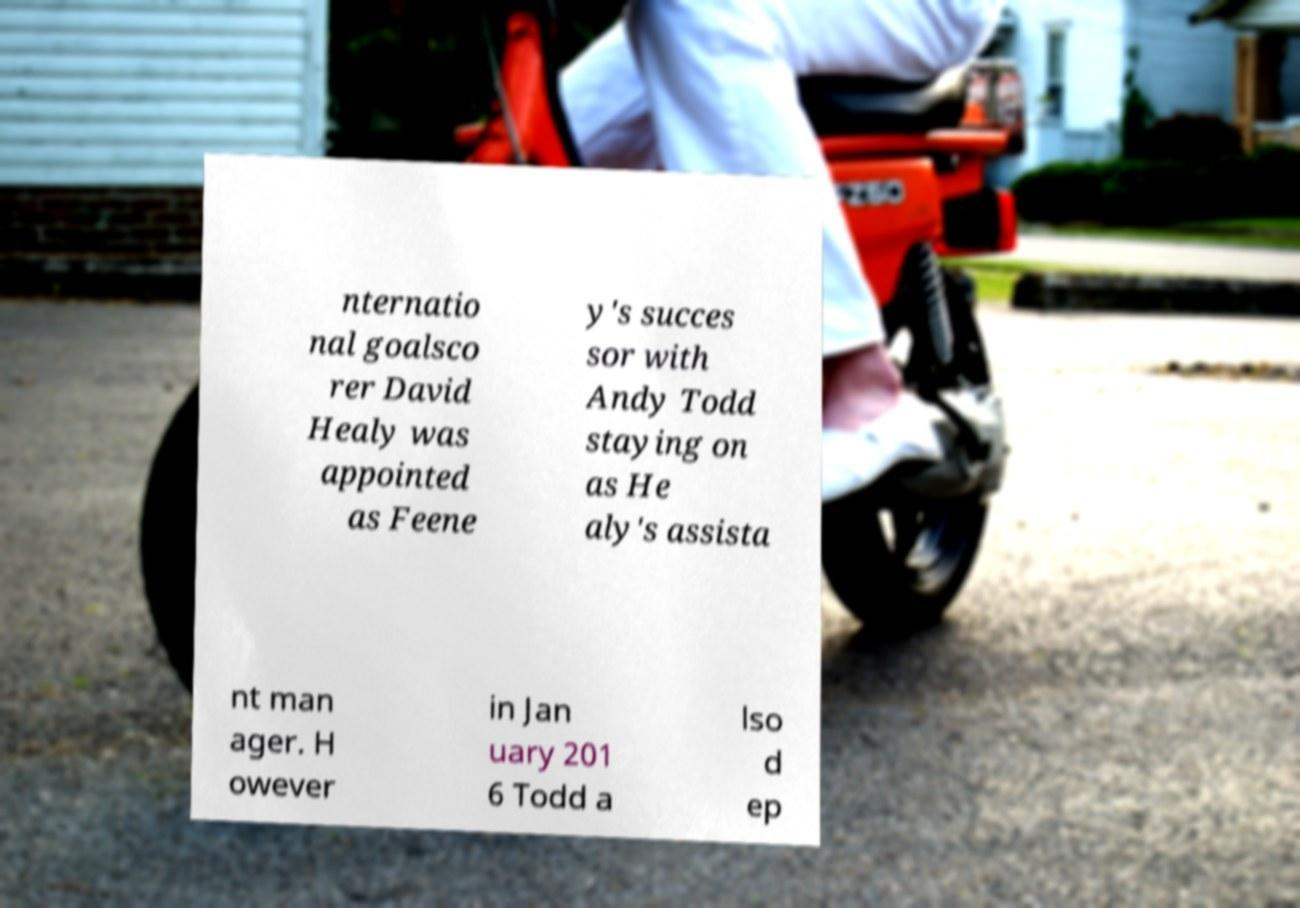For documentation purposes, I need the text within this image transcribed. Could you provide that? nternatio nal goalsco rer David Healy was appointed as Feene y's succes sor with Andy Todd staying on as He aly's assista nt man ager. H owever in Jan uary 201 6 Todd a lso d ep 